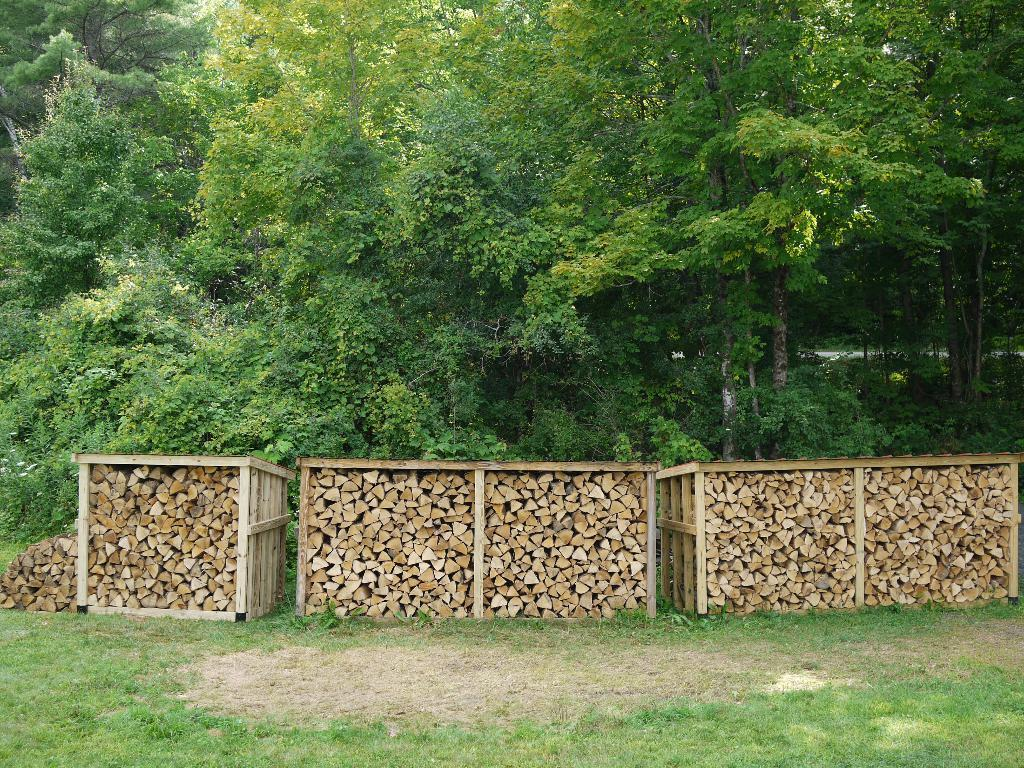What type of material is visible in the bundles in the image? There are bundles of wooden logs in the image. How are the wooden logs stored in the image? The wooden logs are kept in a box. Where is the box with the wooden logs located? The box is on the ground. What is the ground covered with in the image? The ground is covered with grass. What type of vegetation can be seen in the image? There are trees in the image. What type of store is selling honey in the image? There is no store or honey present in the image; it features bundles of wooden logs in a box on the ground. 